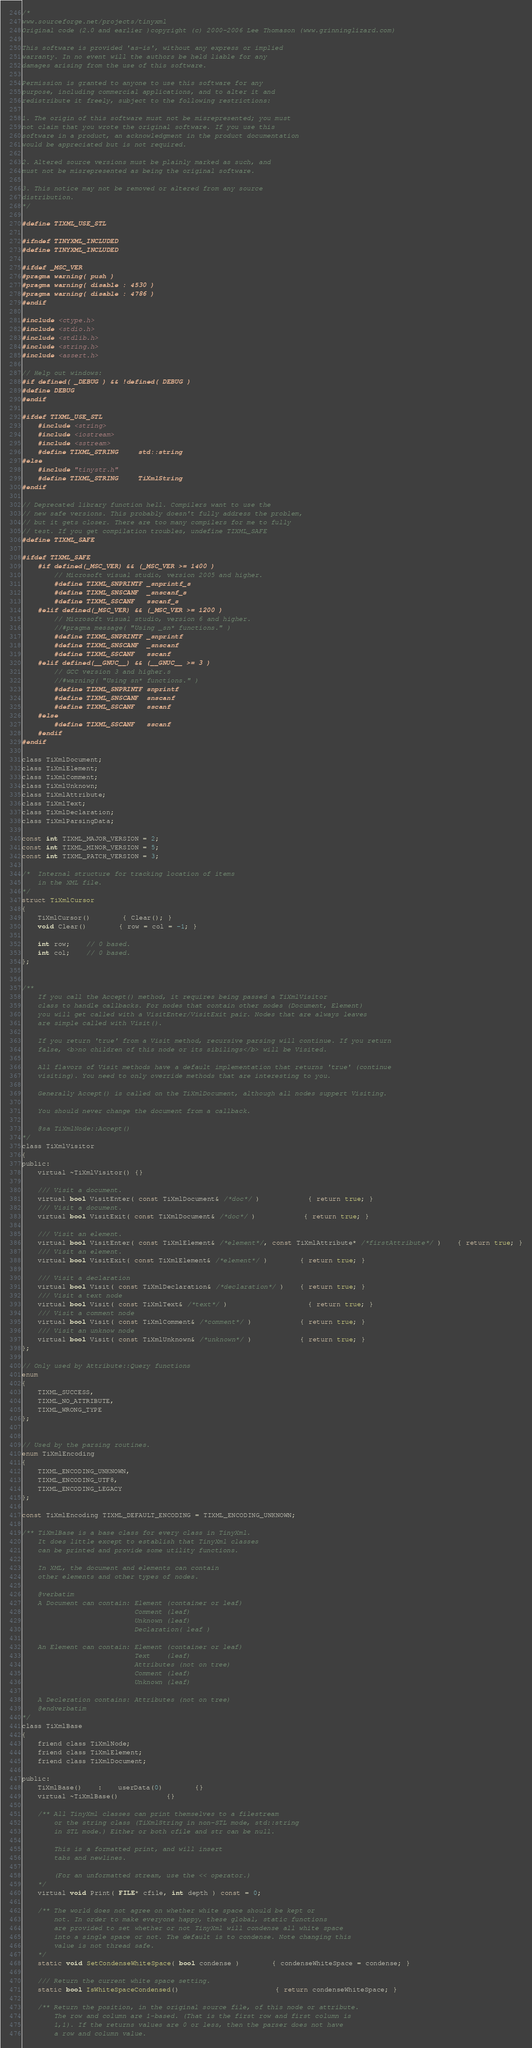<code> <loc_0><loc_0><loc_500><loc_500><_C_>/*
www.sourceforge.net/projects/tinyxml
Original code (2.0 and earlier )copyright (c) 2000-2006 Lee Thomason (www.grinninglizard.com)

This software is provided 'as-is', without any express or implied
warranty. In no event will the authors be held liable for any
damages arising from the use of this software.

Permission is granted to anyone to use this software for any
purpose, including commercial applications, and to alter it and
redistribute it freely, subject to the following restrictions:

1. The origin of this software must not be misrepresented; you must
not claim that you wrote the original software. If you use this
software in a product, an acknowledgment in the product documentation
would be appreciated but is not required.

2. Altered source versions must be plainly marked as such, and
must not be misrepresented as being the original software.

3. This notice may not be removed or altered from any source
distribution.
*/

#define TIXML_USE_STL

#ifndef TINYXML_INCLUDED
#define TINYXML_INCLUDED

#ifdef _MSC_VER
#pragma warning( push )
#pragma warning( disable : 4530 )
#pragma warning( disable : 4786 )
#endif

#include <ctype.h>
#include <stdio.h>
#include <stdlib.h>
#include <string.h>
#include <assert.h>

// Help out windows:
#if defined( _DEBUG ) && !defined( DEBUG )
#define DEBUG
#endif

#ifdef TIXML_USE_STL
	#include <string>
 	#include <iostream>
	#include <sstream>
	#define TIXML_STRING		std::string
#else
	#include "tinystr.h"
	#define TIXML_STRING		TiXmlString
#endif

// Deprecated library function hell. Compilers want to use the
// new safe versions. This probably doesn't fully address the problem,
// but it gets closer. There are too many compilers for me to fully
// test. If you get compilation troubles, undefine TIXML_SAFE
#define TIXML_SAFE

#ifdef TIXML_SAFE
	#if defined(_MSC_VER) && (_MSC_VER >= 1400 )
		// Microsoft visual studio, version 2005 and higher.
		#define TIXML_SNPRINTF _snprintf_s
		#define TIXML_SNSCANF  _snscanf_s
		#define TIXML_SSCANF   sscanf_s
	#elif defined(_MSC_VER) && (_MSC_VER >= 1200 )
		// Microsoft visual studio, version 6 and higher.
		//#pragma message( "Using _sn* functions." )
		#define TIXML_SNPRINTF _snprintf
		#define TIXML_SNSCANF  _snscanf
		#define TIXML_SSCANF   sscanf
	#elif defined(__GNUC__) && (__GNUC__ >= 3 )
		// GCC version 3 and higher.s
		//#warning( "Using sn* functions." )
		#define TIXML_SNPRINTF snprintf
		#define TIXML_SNSCANF  snscanf
		#define TIXML_SSCANF   sscanf
	#else
		#define TIXML_SSCANF   sscanf
	#endif
#endif

class TiXmlDocument;
class TiXmlElement;
class TiXmlComment;
class TiXmlUnknown;
class TiXmlAttribute;
class TiXmlText;
class TiXmlDeclaration;
class TiXmlParsingData;

const int TIXML_MAJOR_VERSION = 2;
const int TIXML_MINOR_VERSION = 5;
const int TIXML_PATCH_VERSION = 3;

/*	Internal structure for tracking location of items
	in the XML file.
*/
struct TiXmlCursor
{
	TiXmlCursor()		{ Clear(); }
	void Clear()		{ row = col = -1; }

	int row;	// 0 based.
	int col;	// 0 based.
};


/**
	If you call the Accept() method, it requires being passed a TiXmlVisitor
	class to handle callbacks. For nodes that contain other nodes (Document, Element)
	you will get called with a VisitEnter/VisitExit pair. Nodes that are always leaves
	are simple called with Visit().

	If you return 'true' from a Visit method, recursive parsing will continue. If you return
	false, <b>no children of this node or its sibilings</b> will be Visited.

	All flavors of Visit methods have a default implementation that returns 'true' (continue
	visiting). You need to only override methods that are interesting to you.

	Generally Accept() is called on the TiXmlDocument, although all nodes suppert Visiting.

	You should never change the document from a callback.

	@sa TiXmlNode::Accept()
*/
class TiXmlVisitor
{
public:
	virtual ~TiXmlVisitor() {}

	/// Visit a document.
	virtual bool VisitEnter( const TiXmlDocument& /*doc*/ )			{ return true; }
	/// Visit a document.
	virtual bool VisitExit( const TiXmlDocument& /*doc*/ )			{ return true; }

	/// Visit an element.
	virtual bool VisitEnter( const TiXmlElement& /*element*/, const TiXmlAttribute* /*firstAttribute*/ )	{ return true; }
	/// Visit an element.
	virtual bool VisitExit( const TiXmlElement& /*element*/ )		{ return true; }

	/// Visit a declaration
	virtual bool Visit( const TiXmlDeclaration& /*declaration*/ )	{ return true; }
	/// Visit a text node
	virtual bool Visit( const TiXmlText& /*text*/ )					{ return true; }
	/// Visit a comment node
	virtual bool Visit( const TiXmlComment& /*comment*/ )			{ return true; }
	/// Visit an unknow node
	virtual bool Visit( const TiXmlUnknown& /*unknown*/ )			{ return true; }
};

// Only used by Attribute::Query functions
enum
{
	TIXML_SUCCESS,
	TIXML_NO_ATTRIBUTE,
	TIXML_WRONG_TYPE
};


// Used by the parsing routines.
enum TiXmlEncoding
{
	TIXML_ENCODING_UNKNOWN,
	TIXML_ENCODING_UTF8,
	TIXML_ENCODING_LEGACY
};

const TiXmlEncoding TIXML_DEFAULT_ENCODING = TIXML_ENCODING_UNKNOWN;

/** TiXmlBase is a base class for every class in TinyXml.
	It does little except to establish that TinyXml classes
	can be printed and provide some utility functions.

	In XML, the document and elements can contain
	other elements and other types of nodes.

	@verbatim
	A Document can contain:	Element	(container or leaf)
							Comment (leaf)
							Unknown (leaf)
							Declaration( leaf )

	An Element can contain:	Element (container or leaf)
							Text	(leaf)
							Attributes (not on tree)
							Comment (leaf)
							Unknown (leaf)

	A Decleration contains: Attributes (not on tree)
	@endverbatim
*/
class TiXmlBase
{
	friend class TiXmlNode;
	friend class TiXmlElement;
	friend class TiXmlDocument;

public:
	TiXmlBase()	:	userData(0)		{}
	virtual ~TiXmlBase()			{}

	/**	All TinyXml classes can print themselves to a filestream
		or the string class (TiXmlString in non-STL mode, std::string
		in STL mode.) Either or both cfile and str can be null.

		This is a formatted print, and will insert
		tabs and newlines.

		(For an unformatted stream, use the << operator.)
	*/
	virtual void Print( FILE* cfile, int depth ) const = 0;

	/**	The world does not agree on whether white space should be kept or
		not. In order to make everyone happy, these global, static functions
		are provided to set whether or not TinyXml will condense all white space
		into a single space or not. The default is to condense. Note changing this
		value is not thread safe.
	*/
	static void SetCondenseWhiteSpace( bool condense )		{ condenseWhiteSpace = condense; }

	/// Return the current white space setting.
	static bool IsWhiteSpaceCondensed()						{ return condenseWhiteSpace; }

	/** Return the position, in the original source file, of this node or attribute.
		The row and column are 1-based. (That is the first row and first column is
		1,1). If the returns values are 0 or less, then the parser does not have
		a row and column value.
</code> 